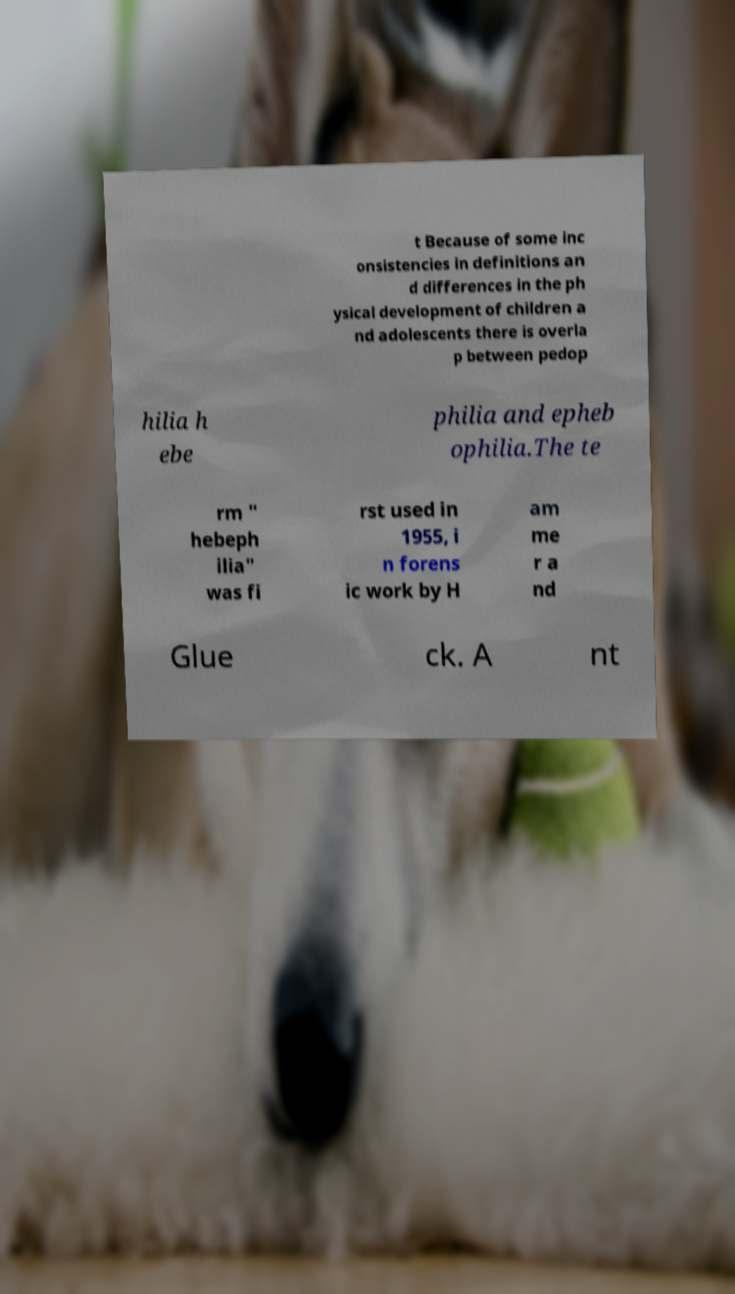Could you assist in decoding the text presented in this image and type it out clearly? t Because of some inc onsistencies in definitions an d differences in the ph ysical development of children a nd adolescents there is overla p between pedop hilia h ebe philia and epheb ophilia.The te rm " hebeph ilia" was fi rst used in 1955, i n forens ic work by H am me r a nd Glue ck. A nt 